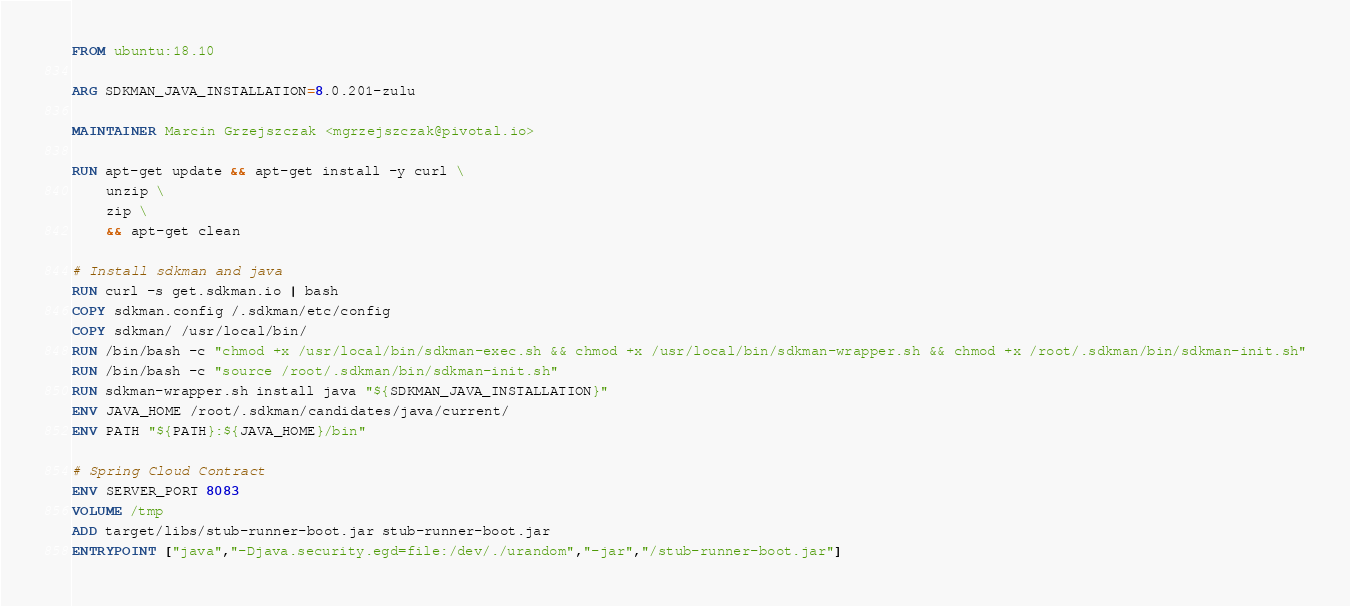<code> <loc_0><loc_0><loc_500><loc_500><_Dockerfile_>FROM ubuntu:18.10

ARG SDKMAN_JAVA_INSTALLATION=8.0.201-zulu

MAINTAINER Marcin Grzejszczak <mgrzejszczak@pivotal.io>

RUN apt-get update && apt-get install -y curl \
    unzip \
    zip \
    && apt-get clean

# Install sdkman and java
RUN curl -s get.sdkman.io | bash
COPY sdkman.config /.sdkman/etc/config
COPY sdkman/ /usr/local/bin/
RUN /bin/bash -c "chmod +x /usr/local/bin/sdkman-exec.sh && chmod +x /usr/local/bin/sdkman-wrapper.sh && chmod +x /root/.sdkman/bin/sdkman-init.sh"
RUN /bin/bash -c "source /root/.sdkman/bin/sdkman-init.sh"
RUN sdkman-wrapper.sh install java "${SDKMAN_JAVA_INSTALLATION}"
ENV JAVA_HOME /root/.sdkman/candidates/java/current/
ENV PATH "${PATH}:${JAVA_HOME}/bin"

# Spring Cloud Contract
ENV SERVER_PORT 8083
VOLUME /tmp
ADD target/libs/stub-runner-boot.jar stub-runner-boot.jar
ENTRYPOINT ["java","-Djava.security.egd=file:/dev/./urandom","-jar","/stub-runner-boot.jar"]
</code> 